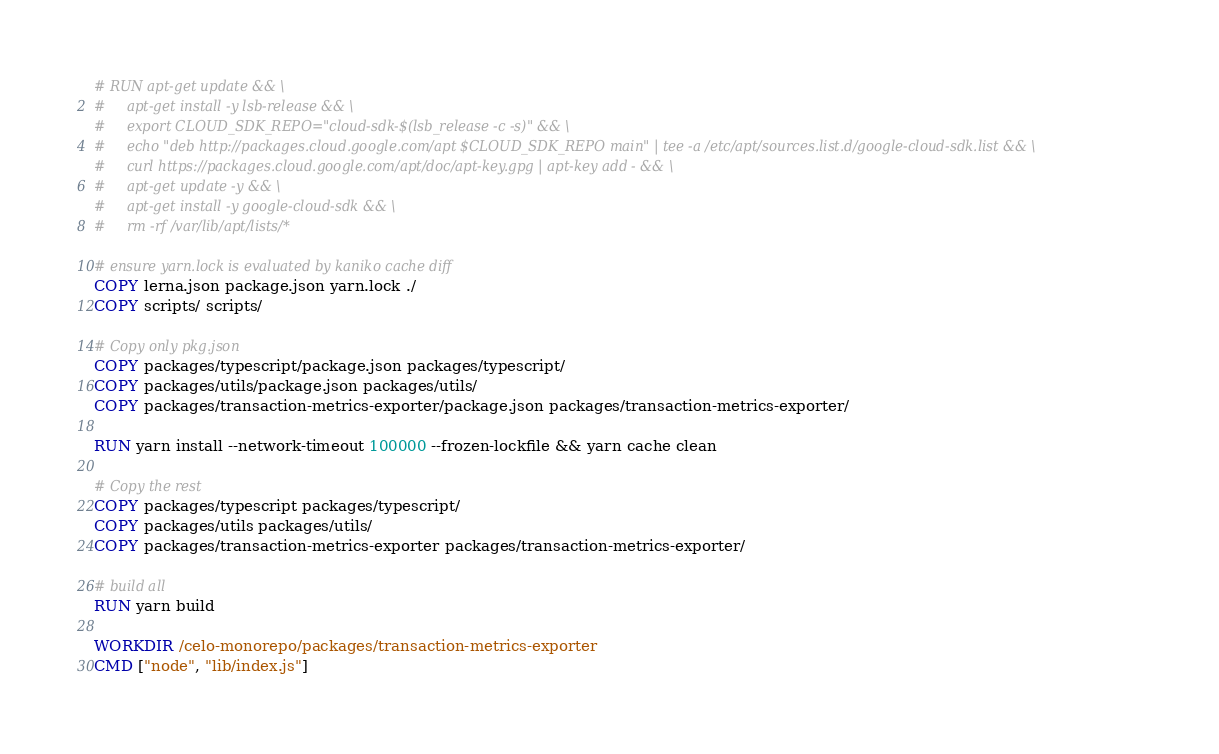<code> <loc_0><loc_0><loc_500><loc_500><_Dockerfile_># RUN apt-get update && \
#     apt-get install -y lsb-release && \
#     export CLOUD_SDK_REPO="cloud-sdk-$(lsb_release -c -s)" && \
#     echo "deb http://packages.cloud.google.com/apt $CLOUD_SDK_REPO main" | tee -a /etc/apt/sources.list.d/google-cloud-sdk.list && \
#     curl https://packages.cloud.google.com/apt/doc/apt-key.gpg | apt-key add - && \
#     apt-get update -y && \
#     apt-get install -y google-cloud-sdk && \
#     rm -rf /var/lib/apt/lists/*

# ensure yarn.lock is evaluated by kaniko cache diff
COPY lerna.json package.json yarn.lock ./
COPY scripts/ scripts/

# Copy only pkg.json
COPY packages/typescript/package.json packages/typescript/
COPY packages/utils/package.json packages/utils/
COPY packages/transaction-metrics-exporter/package.json packages/transaction-metrics-exporter/

RUN yarn install --network-timeout 100000 --frozen-lockfile && yarn cache clean

# Copy the rest
COPY packages/typescript packages/typescript/
COPY packages/utils packages/utils/
COPY packages/transaction-metrics-exporter packages/transaction-metrics-exporter/

# build all
RUN yarn build

WORKDIR /celo-monorepo/packages/transaction-metrics-exporter
CMD ["node", "lib/index.js"]
</code> 